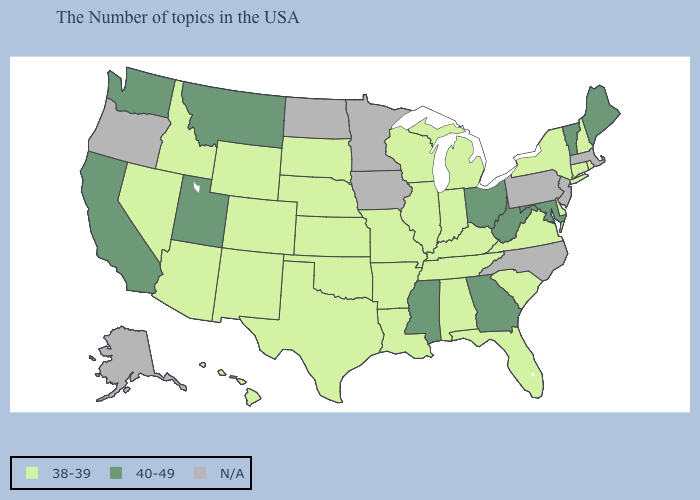Does Virginia have the highest value in the South?
Write a very short answer. No. What is the highest value in the USA?
Keep it brief. 40-49. What is the value of New York?
Be succinct. 38-39. Name the states that have a value in the range N/A?
Be succinct. Massachusetts, New Jersey, Pennsylvania, North Carolina, Minnesota, Iowa, North Dakota, Oregon, Alaska. What is the value of Illinois?
Give a very brief answer. 38-39. Which states hav the highest value in the Northeast?
Write a very short answer. Maine, Vermont. What is the value of Missouri?
Give a very brief answer. 38-39. Name the states that have a value in the range 40-49?
Give a very brief answer. Maine, Vermont, Maryland, West Virginia, Ohio, Georgia, Mississippi, Utah, Montana, California, Washington. Name the states that have a value in the range 40-49?
Be succinct. Maine, Vermont, Maryland, West Virginia, Ohio, Georgia, Mississippi, Utah, Montana, California, Washington. What is the value of Maryland?
Give a very brief answer. 40-49. Name the states that have a value in the range N/A?
Concise answer only. Massachusetts, New Jersey, Pennsylvania, North Carolina, Minnesota, Iowa, North Dakota, Oregon, Alaska. Is the legend a continuous bar?
Answer briefly. No. What is the value of New Hampshire?
Write a very short answer. 38-39. Name the states that have a value in the range 40-49?
Short answer required. Maine, Vermont, Maryland, West Virginia, Ohio, Georgia, Mississippi, Utah, Montana, California, Washington. What is the value of Iowa?
Short answer required. N/A. 